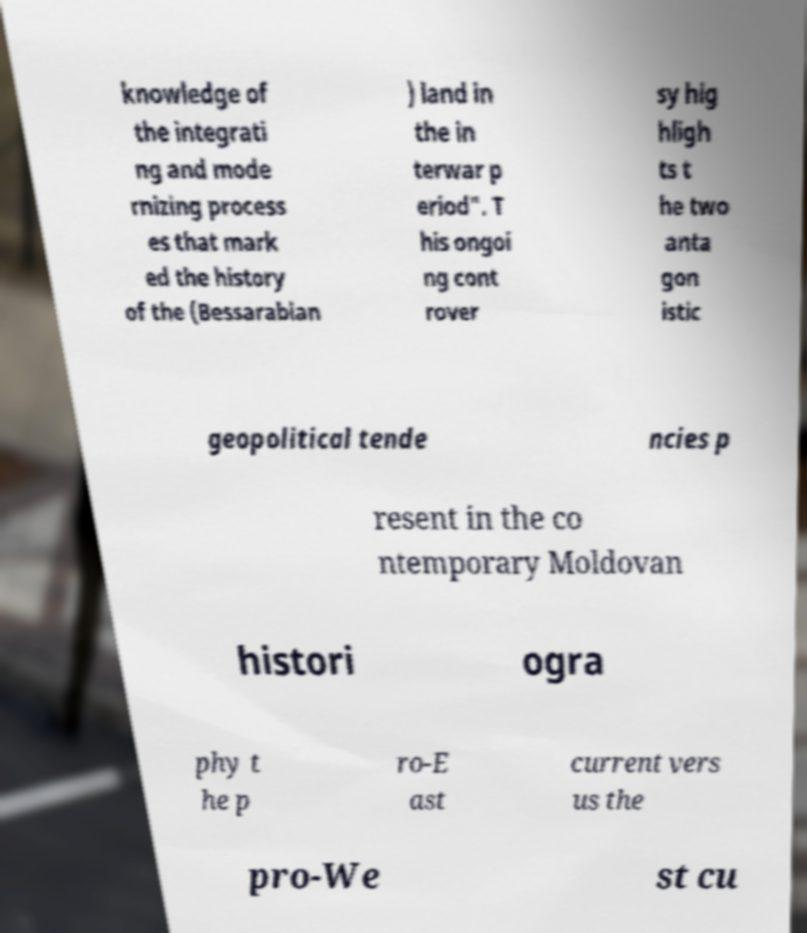Please identify and transcribe the text found in this image. knowledge of the integrati ng and mode rnizing process es that mark ed the history of the (Bessarabian ) land in the in terwar p eriod". T his ongoi ng cont rover sy hig hligh ts t he two anta gon istic geopolitical tende ncies p resent in the co ntemporary Moldovan histori ogra phy t he p ro-E ast current vers us the pro-We st cu 